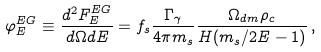<formula> <loc_0><loc_0><loc_500><loc_500>\varphi _ { E } ^ { E G } \equiv \frac { d ^ { 2 } F ^ { E G } _ { E } } { d \Omega d E } = f _ { s } \frac { \Gamma _ { \gamma } } { 4 \pi m _ { s } } \frac { \Omega _ { d m } \rho _ { c } } { H ( m _ { s } / 2 E - 1 ) } \, ,</formula> 